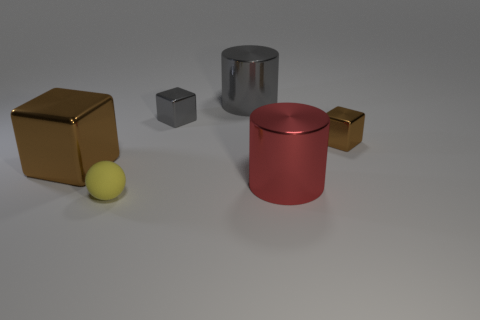Subtract all small metal cubes. How many cubes are left? 1 Add 2 yellow rubber blocks. How many objects exist? 8 Subtract all brown blocks. How many blocks are left? 1 Subtract 2 cubes. How many cubes are left? 1 Subtract all yellow balls. How many brown blocks are left? 2 Subtract 1 gray cylinders. How many objects are left? 5 Subtract all balls. How many objects are left? 5 Subtract all red cylinders. Subtract all red spheres. How many cylinders are left? 1 Subtract all large metal cubes. Subtract all small cyan rubber cubes. How many objects are left? 5 Add 6 large red cylinders. How many large red cylinders are left? 7 